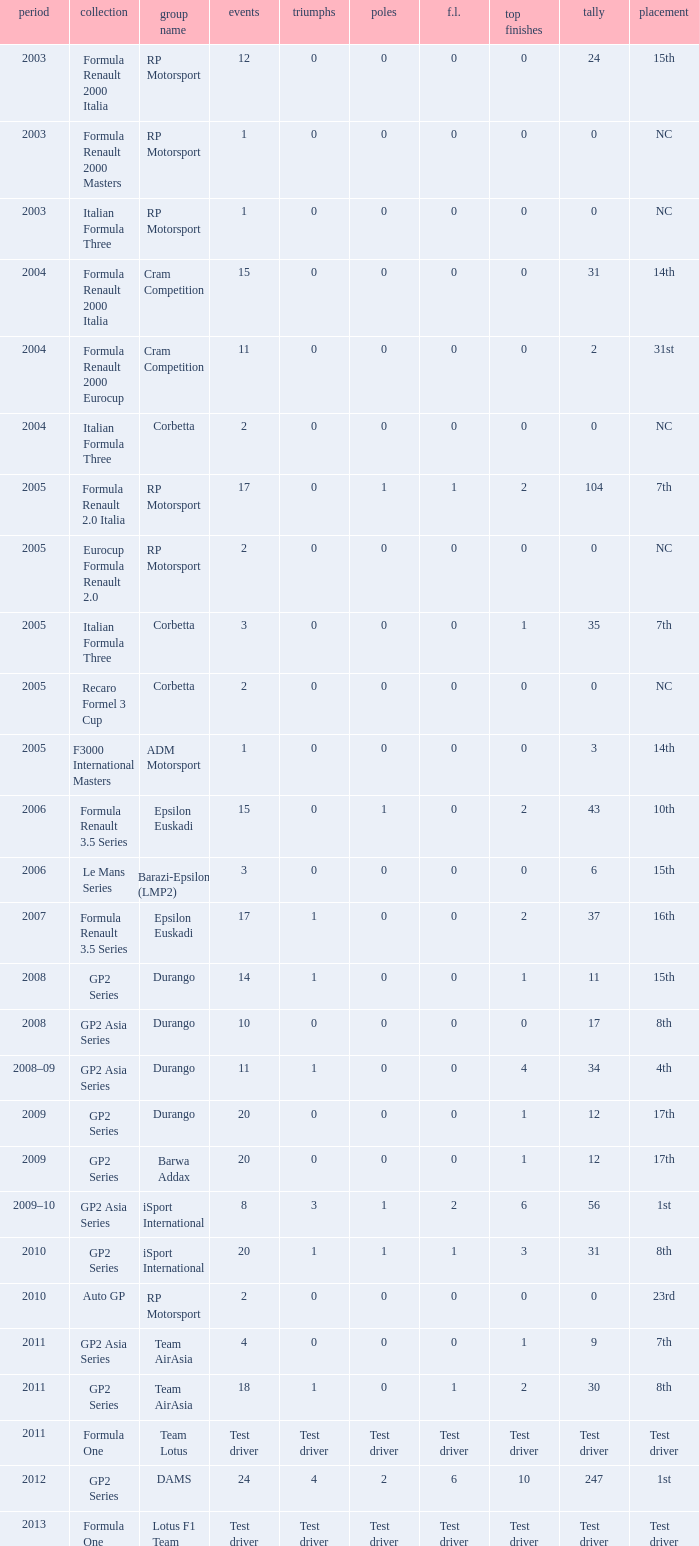What is the number of podiums with 0 wins and 6 points? 0.0. 